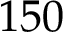<formula> <loc_0><loc_0><loc_500><loc_500>1 5 0</formula> 